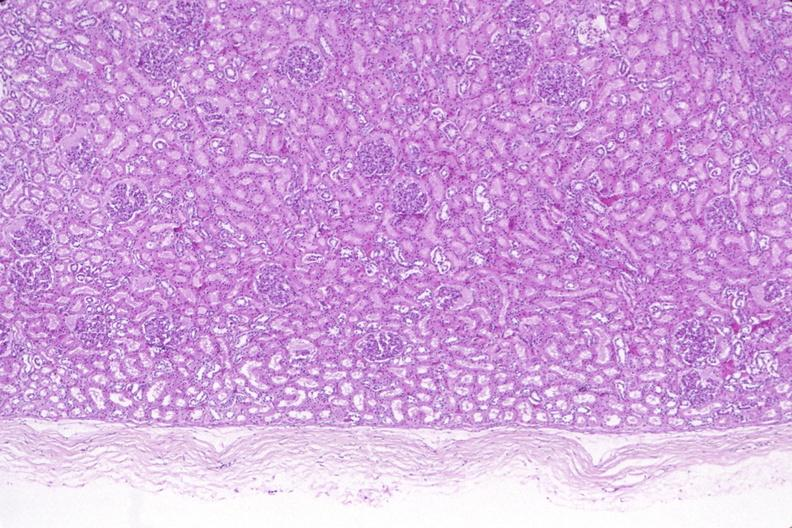where is this?
Answer the question using a single word or phrase. Urinary 